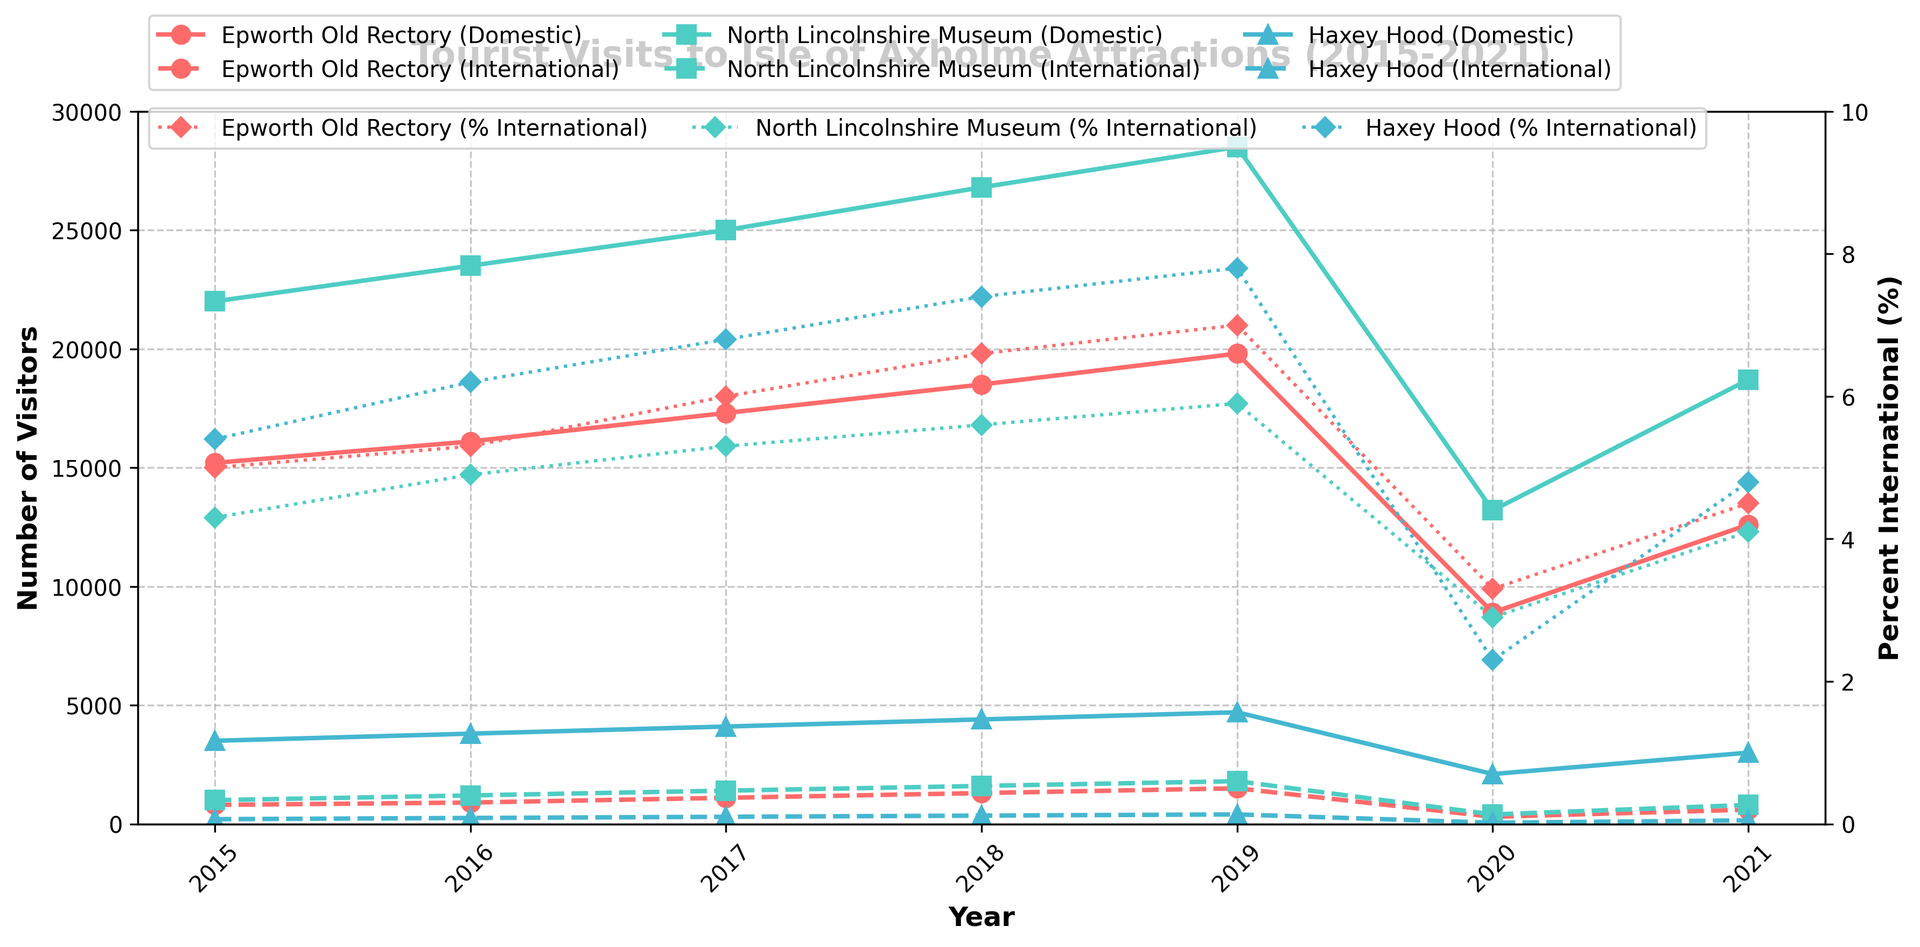How did the number of domestic visitors to Epworth Old Rectory change from 2019 to 2020? The figure shows the number of domestic visitors in 2019 and 2020. In 2019, Epworth Old Rectory had 19,800 domestic visitors. In 2020, it had 8,900. Therefore, the change is 19,800 - 8,900 = 10,900.
Answer: 10,900 In 2021, which attraction had the highest percentage of international visitors? The percentage of international visitors in 2021 can be seen for each attraction. Epworth Old Rectory has 4.5%, North Lincolnshire Museum has 4.1%, and Haxey Hood has 4.8%. Among these, Haxey Hood has the highest percentage.
Answer: Haxey Hood Which attraction experienced the greatest decrease in the number of international visitors from 2019 to 2020? To determine this, we need to compare the number of international visitors in 2019 and 2020 for each attraction. Epworth Old Rectory went from 1,500 to 300 (decrease of 1,200), North Lincolnshire Museum from 1,800 to 400 (decrease of 1,400), and Haxey Hood from 400 to 50 (decrease of 350). The North Lincolnshire Museum experienced the greatest decrease.
Answer: North Lincolnshire Museum What was the overall trend in the percentage of international visitors for Epworth Old Rectory from 2015 to 2021? Examining the percentage values for Epworth Old Rectory from 2015 to 2021, we see a trend: 5.0%, 5.3%, 6.0%, 6.6%, 7.0%, 3.3%, and 4.5%. The percentage increased from 2015 to 2019, then decreased significantly in 2020, and slightly increased again in 2021.
Answer: Increase until 2019, then decrease in 2020, slight increase in 2021 Which year saw the maximum number of domestic visitors for the North Lincolnshire Museum? By examining the graph, the number of domestic visitors to the North Lincolnshire Museum increases each year from 2015 to 2019, drops significantly in 2020, and partially recovers in 2021. The maximum value is in 2019 with 28,500 visitors.
Answer: 2019 Comparing the number of domestic visitors to North Lincolnshire Museum and Epworth Old Rectory in 2018, which was higher, and by how much? In 2018, North Lincolnshire Museum had 26,800 domestic visitors, and Epworth Old Rectory had 18,500. To find the difference: 26,800 - 18,500 = 8,300.
Answer: North Lincolnshire Museum, by 8,300 By how much did the percentage of international visitors to Haxey Hood change from 2019 to 2020? The percentage of international visitors to Haxey Hood was 7.8% in 2019 and 2.3% in 2020. The difference is 7.8 - 2.3 = 5.5.
Answer: 5.5% Which attraction had a higher number of international visitors in 2017: Epworth Old Rectory or North Lincolnshire Museum? Reviewing the figure for 2017, Epworth Old Rectory had 1,100 international visitors, and North Lincolnshire Museum had 1,400. Therefore, the North Lincolnshire Museum had more international visitors in 2017.
Answer: North Lincolnshire Museum 